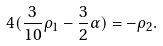<formula> <loc_0><loc_0><loc_500><loc_500>4 ( \frac { 3 } { 1 0 } \rho _ { 1 } - \frac { 3 } { 2 } \alpha ) = - \rho _ { 2 } .</formula> 